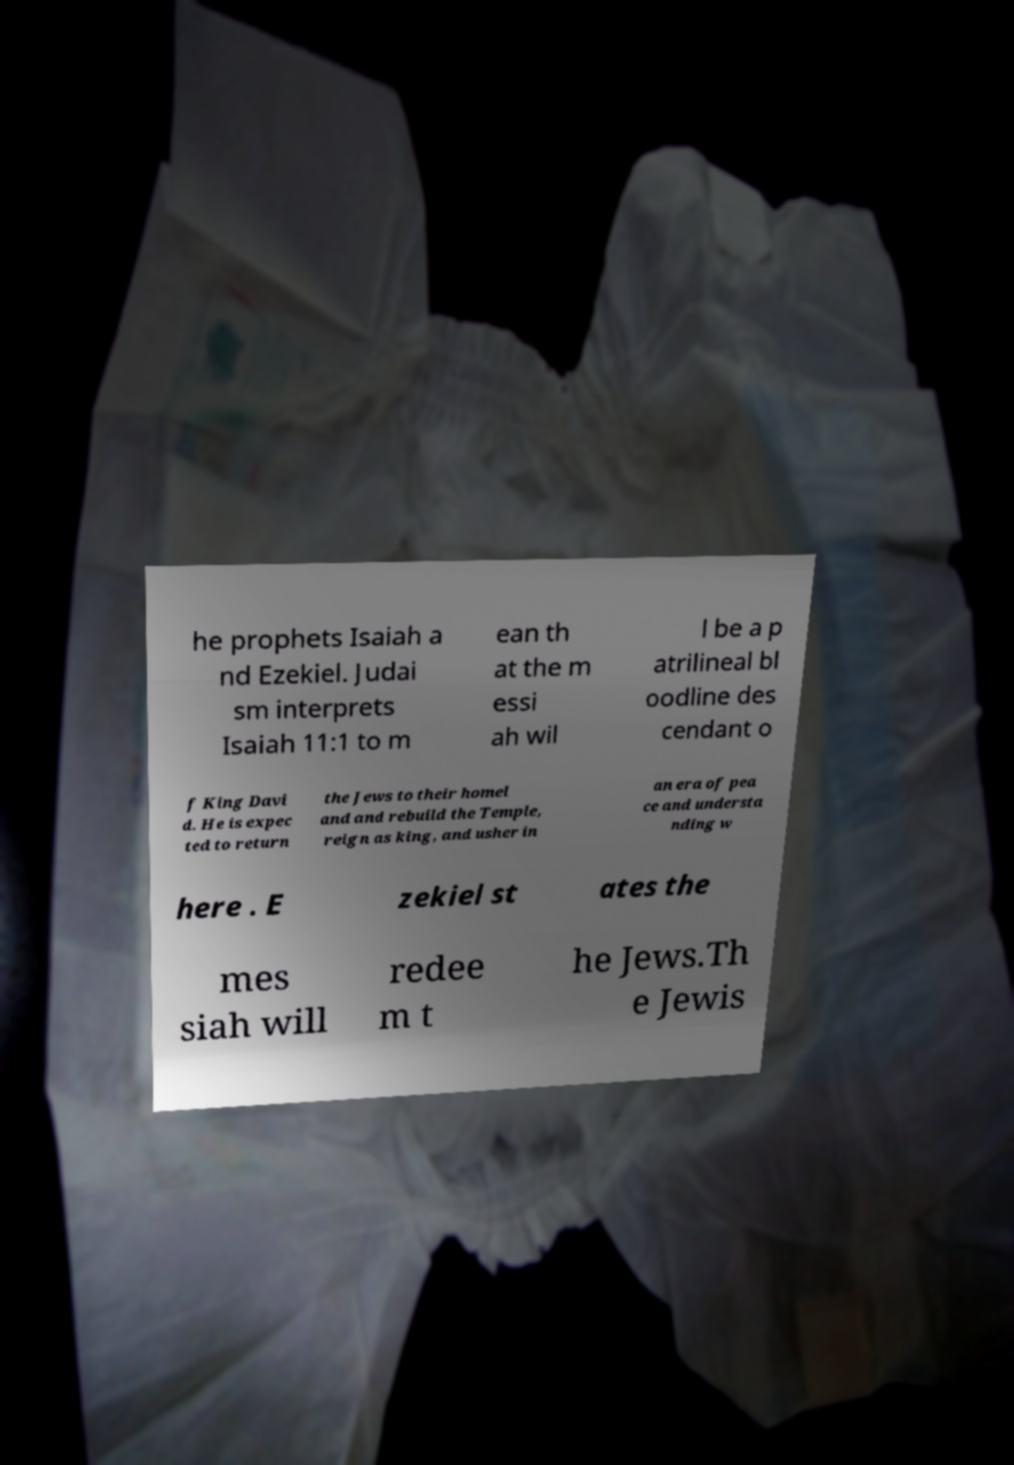I need the written content from this picture converted into text. Can you do that? he prophets Isaiah a nd Ezekiel. Judai sm interprets Isaiah 11:1 to m ean th at the m essi ah wil l be a p atrilineal bl oodline des cendant o f King Davi d. He is expec ted to return the Jews to their homel and and rebuild the Temple, reign as king, and usher in an era of pea ce and understa nding w here . E zekiel st ates the mes siah will redee m t he Jews.Th e Jewis 